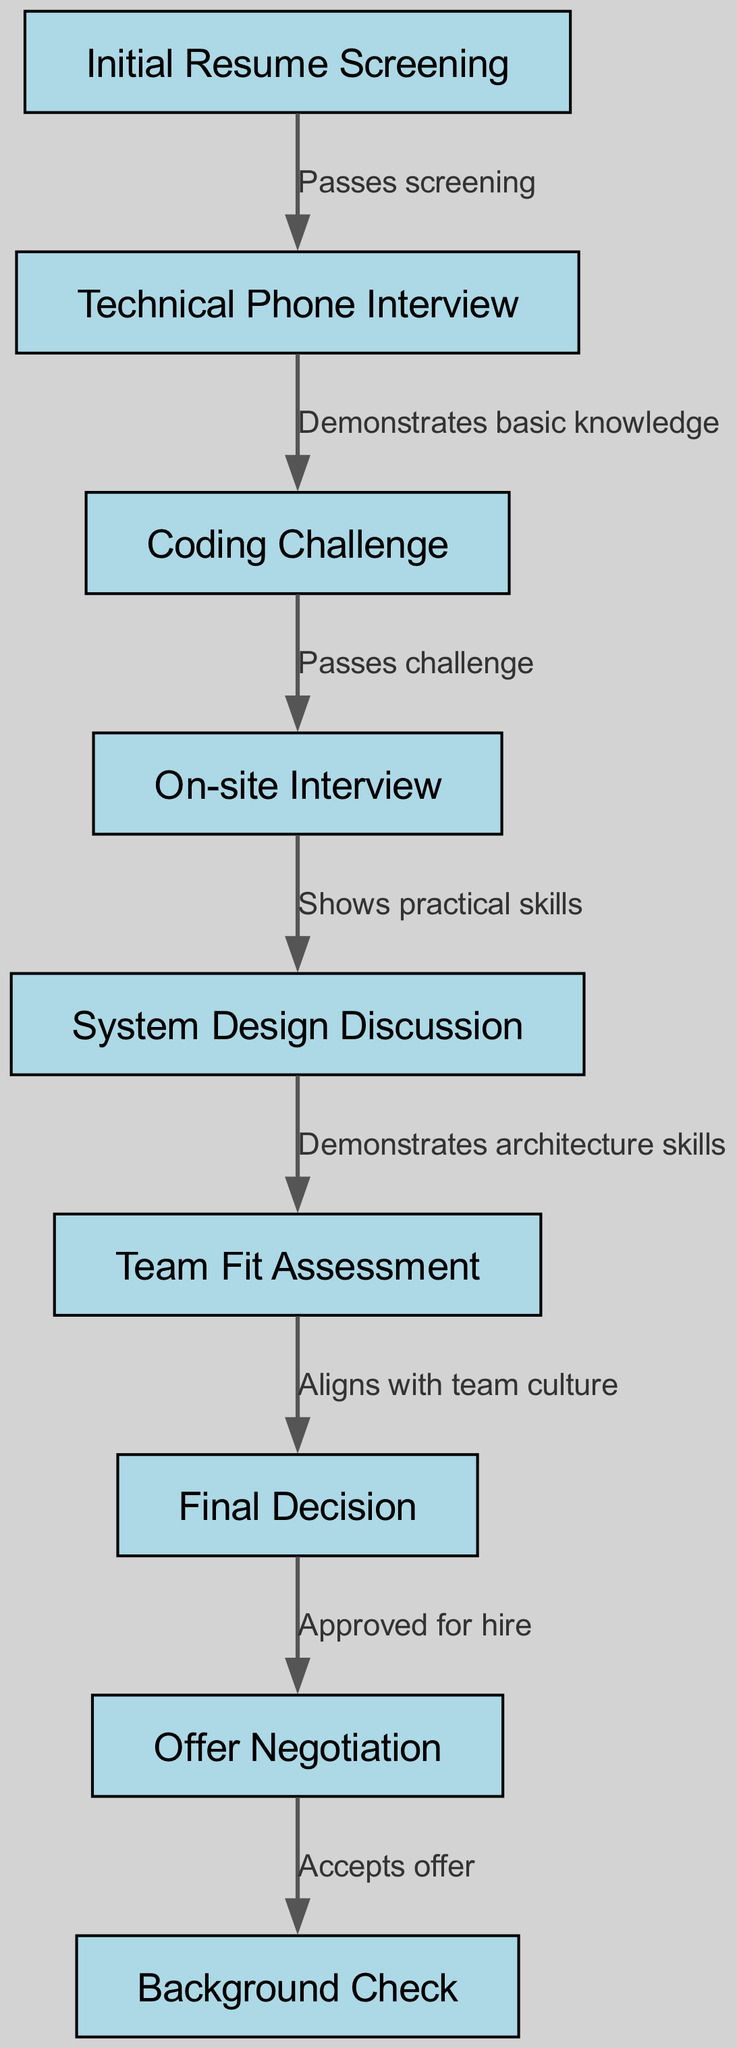What is the first step in the candidate evaluation process? The diagram shows that the first step in the candidate evaluation process is "Initial Resume Screening". This is clearly labeled as the starting node in the directed graph.
Answer: Initial Resume Screening How many total nodes are in the diagram? The diagram contains a total of eight nodes which represent the major steps in the candidate evaluation process. This can be counted directly from the provided node list.
Answer: Eight What occurs after the Technical Phone Interview? According to the diagram, after the "Technical Phone Interview", the next step is "Coding Challenge", as indicated by the directed edge connecting these two nodes.
Answer: Coding Challenge What does a candidate need to demonstrate in order to progress from the Technical Phone Interview to the Coding Challenge? The edge from "Technical Phone Interview" to "Coding Challenge" is labeled "Demonstrates basic knowledge", indicating that this is the requirement for progression.
Answer: Demonstrates basic knowledge Which step follows the Team Fit Assessment? The diagram indicates that the step following the "Team Fit Assessment" is the "Final Decision", as shown by the directed edge from one node to the next.
Answer: Final Decision What is required for a candidate to reach the Offer Negotiation stage? The candidate must be "Approved for hire", which is the condition that enables the transition from "Final Decision" to "Offer Negotiation", as described by the corresponding edge in the diagram.
Answer: Approved for hire How does a candidate complete the evaluation process? The evaluation process is completed once the candidate "Accepts offer", which is the final event leading from "Offer Negotiation" to the "Background Check" stage according to the diagram's flow.
Answer: Accepts offer What skill set is evaluated during the System Design Discussion? The edge from "System Design Discussion" to "Team Fit Assessment" indicates that candidates are evaluated on their "Demonstrates architecture skills", which is what is necessary for advancement to the next step.
Answer: Demonstrates architecture skills 